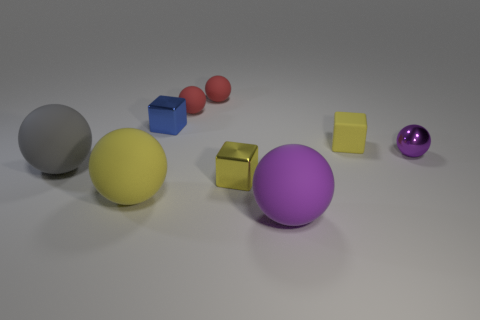Subtract all small blue metal blocks. How many blocks are left? 2 Subtract 2 balls. How many balls are left? 4 Subtract all blue cubes. How many cubes are left? 2 Add 9 small cyan matte things. How many small cyan matte things exist? 9 Subtract 1 yellow balls. How many objects are left? 8 Subtract all blocks. How many objects are left? 6 Subtract all cyan cubes. Subtract all purple cylinders. How many cubes are left? 3 Subtract all yellow balls. How many blue cubes are left? 1 Subtract all purple spheres. Subtract all purple metal objects. How many objects are left? 6 Add 6 big purple matte things. How many big purple matte things are left? 7 